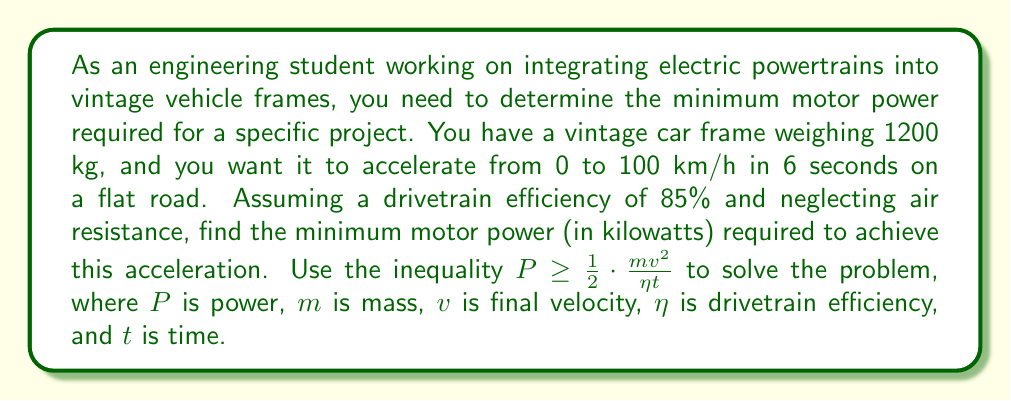Solve this math problem. To solve this problem, we'll use the given inequality and plug in the known values:

$P \geq \frac{1}{2} \cdot \frac{m v^2}{\eta t}$

Where:
$m = 1200$ kg
$v = 100$ km/h = $27.78$ m/s (converting km/h to m/s)
$\eta = 0.85$ (85% efficiency)
$t = 6$ seconds

Substituting these values into the inequality:

$$P \geq \frac{1}{2} \cdot \frac{1200 \cdot (27.78)^2}{0.85 \cdot 6}$$

Now, let's calculate step by step:

1. Calculate $v^2$:
   $27.78^2 = 771.73$ m²/s²

2. Multiply $m$ and $v^2$:
   $1200 \cdot 771.73 = 926,076$ kg·m²/s²

3. Divide by $\eta$ and $t$:
   $\frac{926,076}{0.85 \cdot 6} = 181,584.31$ W

4. Multiply by $\frac{1}{2}$:
   $\frac{1}{2} \cdot 181,584.31 = 90,792.16$ W

5. Convert watts to kilowatts:
   $90,792.16$ W = $90.79$ kW

Therefore, the minimum motor power required is approximately 90.79 kW.
Answer: The minimum motor power required is 90.79 kW. 